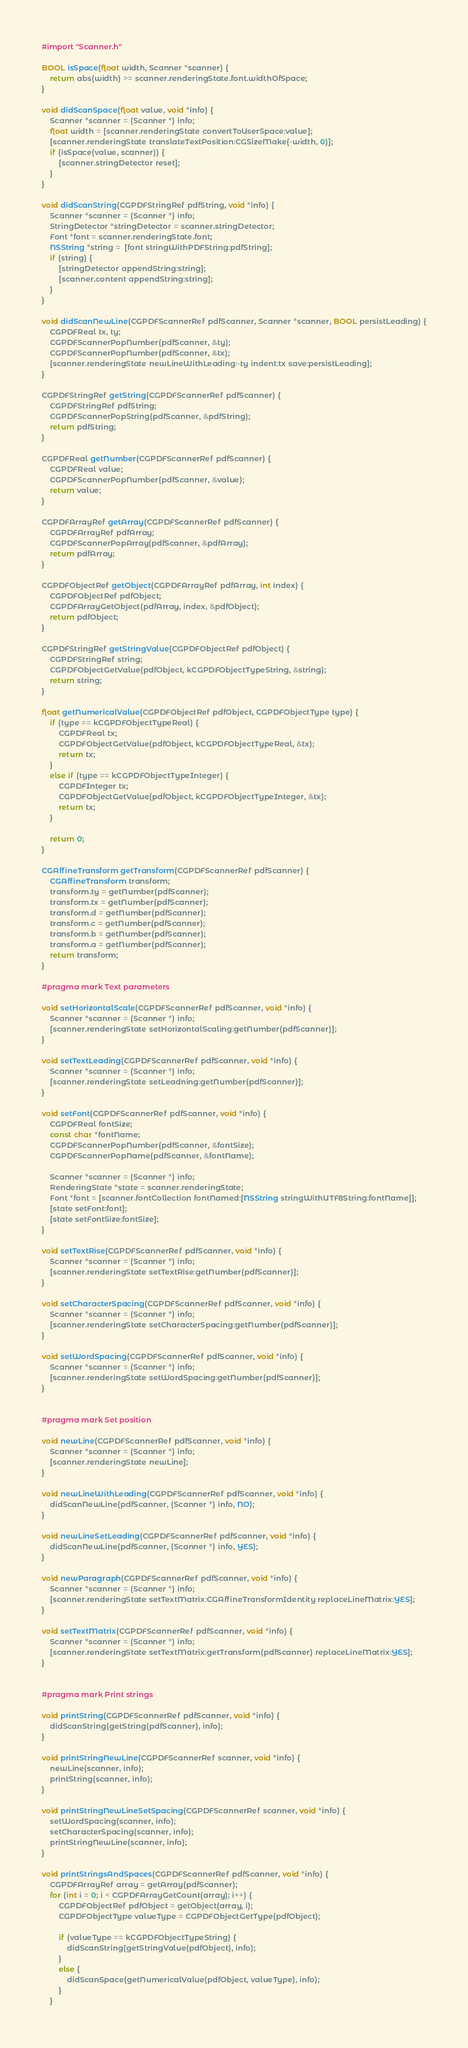Convert code to text. <code><loc_0><loc_0><loc_500><loc_500><_ObjectiveC_>#import "Scanner.h"

BOOL isSpace(float width, Scanner *scanner) {
	return abs(width) >= scanner.renderingState.font.widthOfSpace;
}

void didScanSpace(float value, void *info) {
	Scanner *scanner = (Scanner *) info;
    float width = [scanner.renderingState convertToUserSpace:value];
    [scanner.renderingState translateTextPosition:CGSizeMake(-width, 0)];
    if (isSpace(value, scanner)) {
        [scanner.stringDetector reset];
    }
}

void didScanString(CGPDFStringRef pdfString, void *info) {
	Scanner *scanner = (Scanner *) info;
	StringDetector *stringDetector = scanner.stringDetector;
	Font *font = scanner.renderingState.font;
    NSString *string =  [font stringWithPDFString:pdfString];
    if (string) {
        [stringDetector appendString:string];
        [scanner.content appendString:string];
    }
}

void didScanNewLine(CGPDFScannerRef pdfScanner, Scanner *scanner, BOOL persistLeading) {
	CGPDFReal tx, ty;
	CGPDFScannerPopNumber(pdfScanner, &ty);
	CGPDFScannerPopNumber(pdfScanner, &tx);
	[scanner.renderingState newLineWithLeading:-ty indent:tx save:persistLeading];
}

CGPDFStringRef getString(CGPDFScannerRef pdfScanner) {
	CGPDFStringRef pdfString;
	CGPDFScannerPopString(pdfScanner, &pdfString);
	return pdfString;
}

CGPDFReal getNumber(CGPDFScannerRef pdfScanner) {
	CGPDFReal value;
	CGPDFScannerPopNumber(pdfScanner, &value);
	return value;
}

CGPDFArrayRef getArray(CGPDFScannerRef pdfScanner) {
	CGPDFArrayRef pdfArray;
	CGPDFScannerPopArray(pdfScanner, &pdfArray);
	return pdfArray;
}

CGPDFObjectRef getObject(CGPDFArrayRef pdfArray, int index) {
	CGPDFObjectRef pdfObject;
	CGPDFArrayGetObject(pdfArray, index, &pdfObject);
	return pdfObject;
}

CGPDFStringRef getStringValue(CGPDFObjectRef pdfObject) {
	CGPDFStringRef string;
	CGPDFObjectGetValue(pdfObject, kCGPDFObjectTypeString, &string);
	return string;
}

float getNumericalValue(CGPDFObjectRef pdfObject, CGPDFObjectType type) {
	if (type == kCGPDFObjectTypeReal) {
		CGPDFReal tx;
		CGPDFObjectGetValue(pdfObject, kCGPDFObjectTypeReal, &tx);
		return tx;
	}
	else if (type == kCGPDFObjectTypeInteger) {
		CGPDFInteger tx;
		CGPDFObjectGetValue(pdfObject, kCGPDFObjectTypeInteger, &tx);
		return tx;
	}

	return 0;
}

CGAffineTransform getTransform(CGPDFScannerRef pdfScanner) {
	CGAffineTransform transform;
	transform.ty = getNumber(pdfScanner);
	transform.tx = getNumber(pdfScanner);
	transform.d = getNumber(pdfScanner);
	transform.c = getNumber(pdfScanner);
	transform.b = getNumber(pdfScanner);
	transform.a = getNumber(pdfScanner);
	return transform;
}

#pragma mark Text parameters

void setHorizontalScale(CGPDFScannerRef pdfScanner, void *info) {
	Scanner *scanner = (Scanner *) info;
	[scanner.renderingState setHorizontalScaling:getNumber(pdfScanner)];
}

void setTextLeading(CGPDFScannerRef pdfScanner, void *info) {
	Scanner *scanner = (Scanner *) info;
	[scanner.renderingState setLeadning:getNumber(pdfScanner)];
}

void setFont(CGPDFScannerRef pdfScanner, void *info) {
	CGPDFReal fontSize;
	const char *fontName;
	CGPDFScannerPopNumber(pdfScanner, &fontSize);
	CGPDFScannerPopName(pdfScanner, &fontName);
	
	Scanner *scanner = (Scanner *) info;
	RenderingState *state = scanner.renderingState;
	Font *font = [scanner.fontCollection fontNamed:[NSString stringWithUTF8String:fontName]];
	[state setFont:font];
	[state setFontSize:fontSize];
}

void setTextRise(CGPDFScannerRef pdfScanner, void *info) {
	Scanner *scanner = (Scanner *) info;
	[scanner.renderingState setTextRise:getNumber(pdfScanner)];
}

void setCharacterSpacing(CGPDFScannerRef pdfScanner, void *info) {
	Scanner *scanner = (Scanner *) info;
	[scanner.renderingState setCharacterSpacing:getNumber(pdfScanner)];
}

void setWordSpacing(CGPDFScannerRef pdfScanner, void *info) {
	Scanner *scanner = (Scanner *) info;
	[scanner.renderingState setWordSpacing:getNumber(pdfScanner)];
}


#pragma mark Set position

void newLine(CGPDFScannerRef pdfScanner, void *info) {
	Scanner *scanner = (Scanner *) info;
	[scanner.renderingState newLine];
}

void newLineWithLeading(CGPDFScannerRef pdfScanner, void *info) {
	didScanNewLine(pdfScanner, (Scanner *) info, NO);
}

void newLineSetLeading(CGPDFScannerRef pdfScanner, void *info) {
	didScanNewLine(pdfScanner, (Scanner *) info, YES);
}

void newParagraph(CGPDFScannerRef pdfScanner, void *info) {
	Scanner *scanner = (Scanner *) info;
	[scanner.renderingState setTextMatrix:CGAffineTransformIdentity replaceLineMatrix:YES];
}

void setTextMatrix(CGPDFScannerRef pdfScanner, void *info) {
	Scanner *scanner = (Scanner *) info;
	[scanner.renderingState setTextMatrix:getTransform(pdfScanner) replaceLineMatrix:YES];
}


#pragma mark Print strings

void printString(CGPDFScannerRef pdfScanner, void *info) {
	didScanString(getString(pdfScanner), info);
}

void printStringNewLine(CGPDFScannerRef scanner, void *info) {
	newLine(scanner, info);
	printString(scanner, info);
}

void printStringNewLineSetSpacing(CGPDFScannerRef scanner, void *info) {
	setWordSpacing(scanner, info);
	setCharacterSpacing(scanner, info);
	printStringNewLine(scanner, info);
}

void printStringsAndSpaces(CGPDFScannerRef pdfScanner, void *info) {
	CGPDFArrayRef array = getArray(pdfScanner);
	for (int i = 0; i < CGPDFArrayGetCount(array); i++) {
		CGPDFObjectRef pdfObject = getObject(array, i);
		CGPDFObjectType valueType = CGPDFObjectGetType(pdfObject);

		if (valueType == kCGPDFObjectTypeString) {
			didScanString(getStringValue(pdfObject), info);
		}
		else {
			didScanSpace(getNumericalValue(pdfObject, valueType), info);
		}
	}</code> 